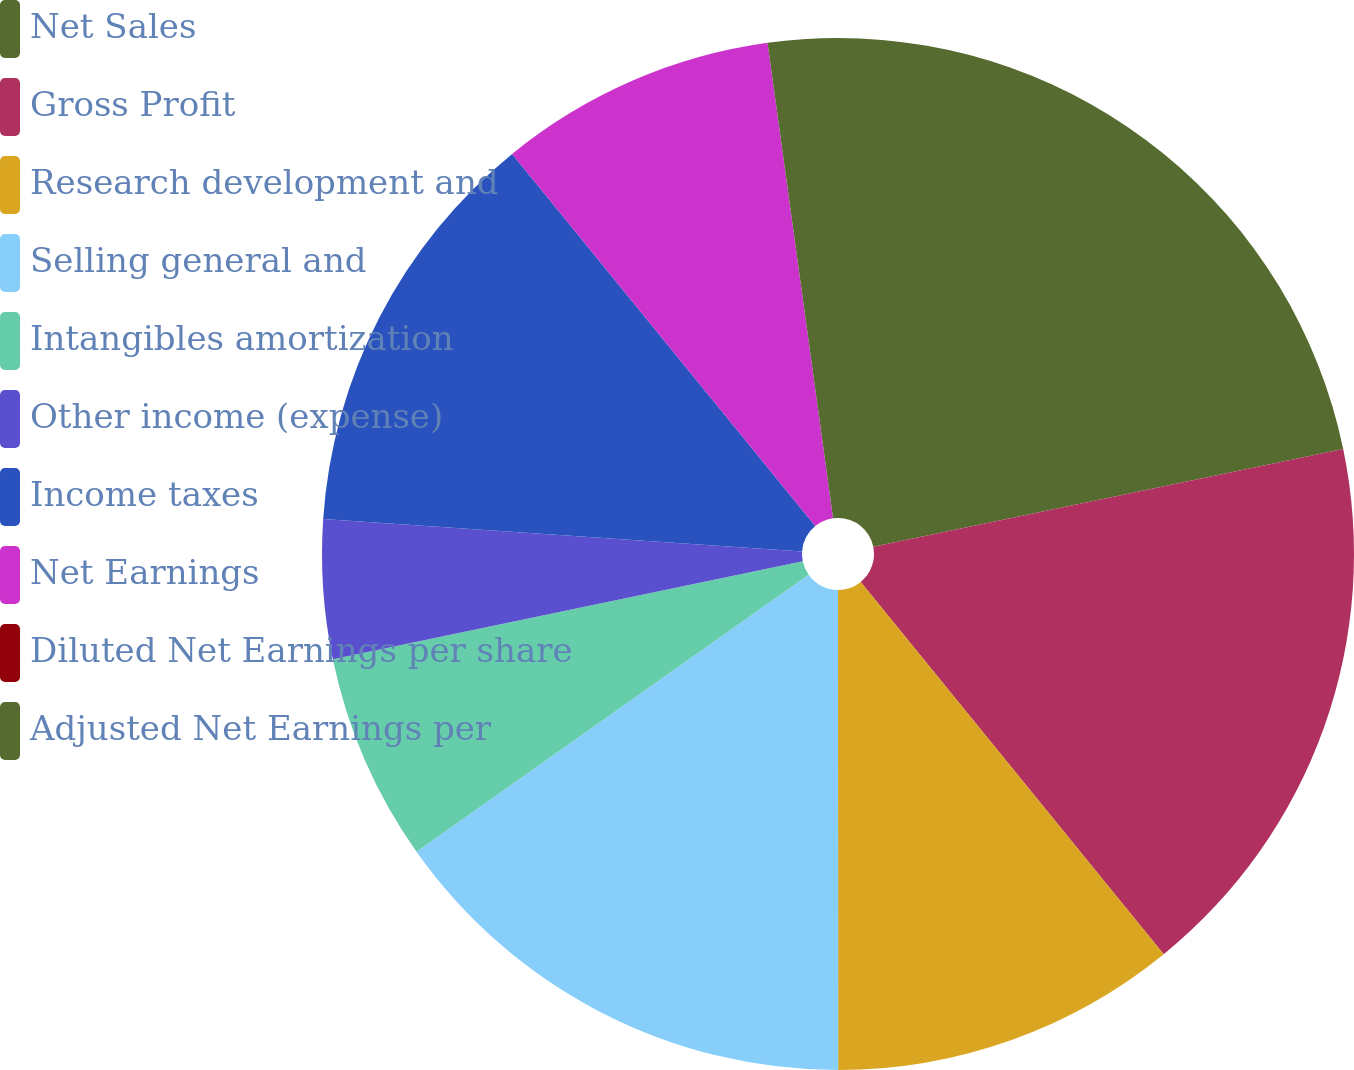Convert chart to OTSL. <chart><loc_0><loc_0><loc_500><loc_500><pie_chart><fcel>Net Sales<fcel>Gross Profit<fcel>Research development and<fcel>Selling general and<fcel>Intangibles amortization<fcel>Other income (expense)<fcel>Income taxes<fcel>Net Earnings<fcel>Diluted Net Earnings per share<fcel>Adjusted Net Earnings per<nl><fcel>21.74%<fcel>17.39%<fcel>10.87%<fcel>15.22%<fcel>6.52%<fcel>4.35%<fcel>13.04%<fcel>8.7%<fcel>0.0%<fcel>2.18%<nl></chart> 